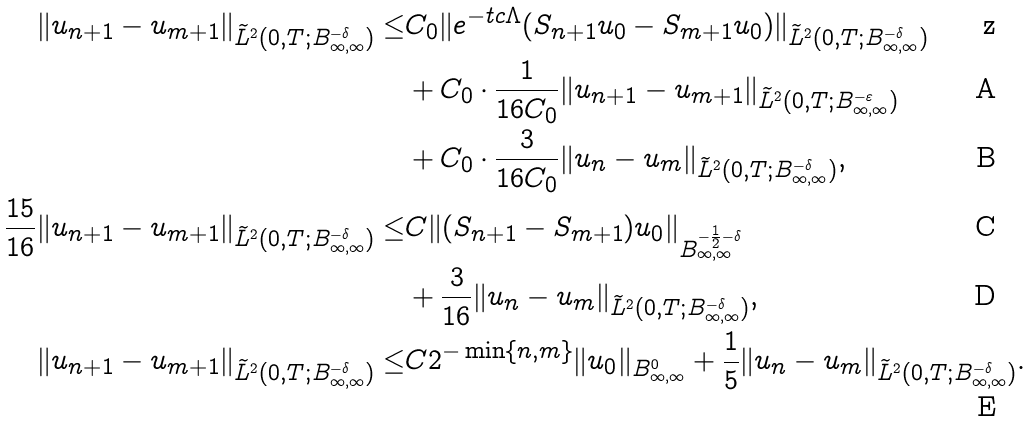<formula> <loc_0><loc_0><loc_500><loc_500>\| u _ { n + 1 } - u _ { m + 1 } \| _ { \widetilde { L } ^ { 2 } ( 0 , T ; B ^ { - \delta } _ { \infty , \infty } ) } \leq & C _ { 0 } \| e ^ { - t c \Lambda } ( S _ { n + 1 } u _ { 0 } - S _ { m + 1 } u _ { 0 } ) \| _ { \widetilde { L } ^ { 2 } ( 0 , T ; B ^ { - \delta } _ { \infty , \infty } ) } \\ & + C _ { 0 } \cdot \frac { 1 } { 1 6 C _ { 0 } } \| u _ { n + 1 } - u _ { m + 1 } \| _ { \widetilde { L } ^ { 2 } ( 0 , T ; B ^ { - \varepsilon } _ { \infty , \infty } ) } \\ & + C _ { 0 } \cdot \frac { 3 } { 1 6 C _ { 0 } } \| u _ { n } - u _ { m } \| _ { \widetilde { L } ^ { 2 } ( 0 , T ; B ^ { - \delta } _ { \infty , \infty } ) } , \\ \frac { 1 5 } { 1 6 } \| u _ { n + 1 } - u _ { m + 1 } \| _ { \widetilde { L } ^ { 2 } ( 0 , T ; B ^ { - \delta } _ { \infty , \infty } ) } \leq & C \| ( S _ { n + 1 } - S _ { m + 1 } ) u _ { 0 } \| _ { B ^ { - \frac { 1 } { 2 } - \delta } _ { \infty , \infty } } \\ & + \frac { 3 } { 1 6 } \| u _ { n } - u _ { m } \| _ { \widetilde { L } ^ { 2 } ( 0 , T ; B ^ { - \delta } _ { \infty , \infty } ) } , \\ \| u _ { n + 1 } - u _ { m + 1 } \| _ { \widetilde { L } ^ { 2 } ( 0 , T ; B ^ { - \delta } _ { \infty , \infty } ) } \leq & C 2 ^ { - \min \{ n , m \} } \| u _ { 0 } \| _ { B ^ { 0 } _ { \infty , \infty } } + \frac { 1 } { 5 } \| u _ { n } - u _ { m } \| _ { \widetilde { L } ^ { 2 } ( 0 , T ; B ^ { - \delta } _ { \infty , \infty } ) } .</formula> 